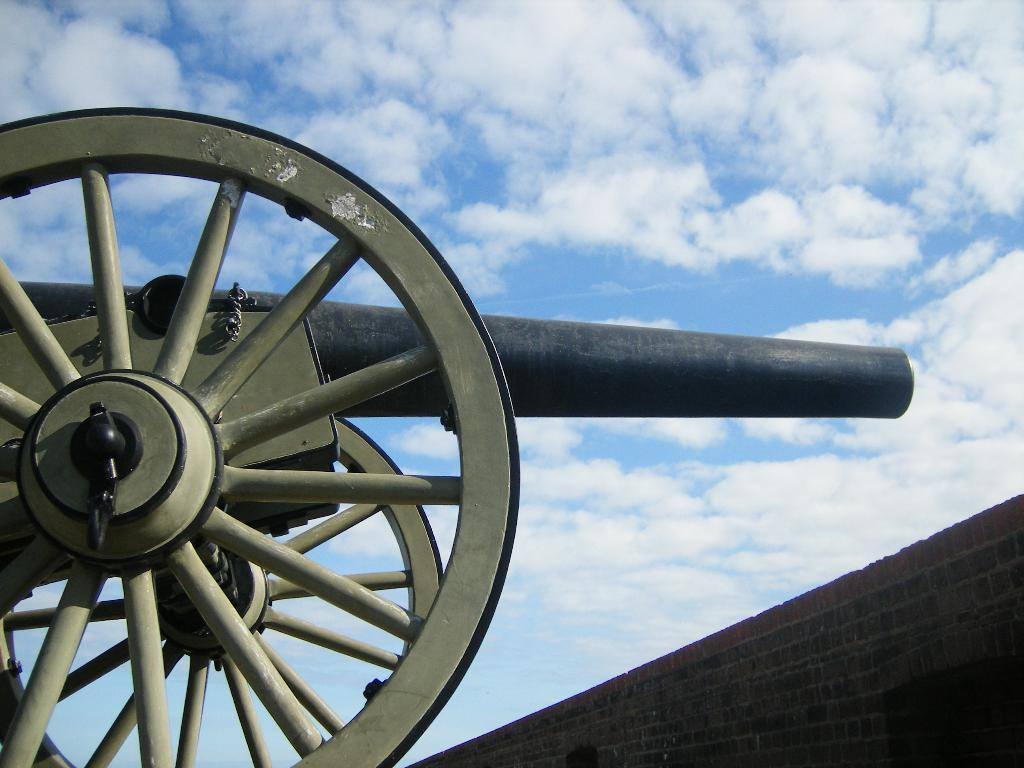What is the main object in the image? There is a cannon in the image. What is located behind the cannon? There is a wall in the image. What can be seen above the cannon and wall? The sky is visible in the image. What is present in the sky? Clouds are present in the sky. What type of chalk is being used to draw on the cannon in the image? There is no chalk or drawing present on the cannon in the image. What kind of picture is hanging on the wall behind the cannon? There is no picture hanging on the wall behind the cannon in the image. 